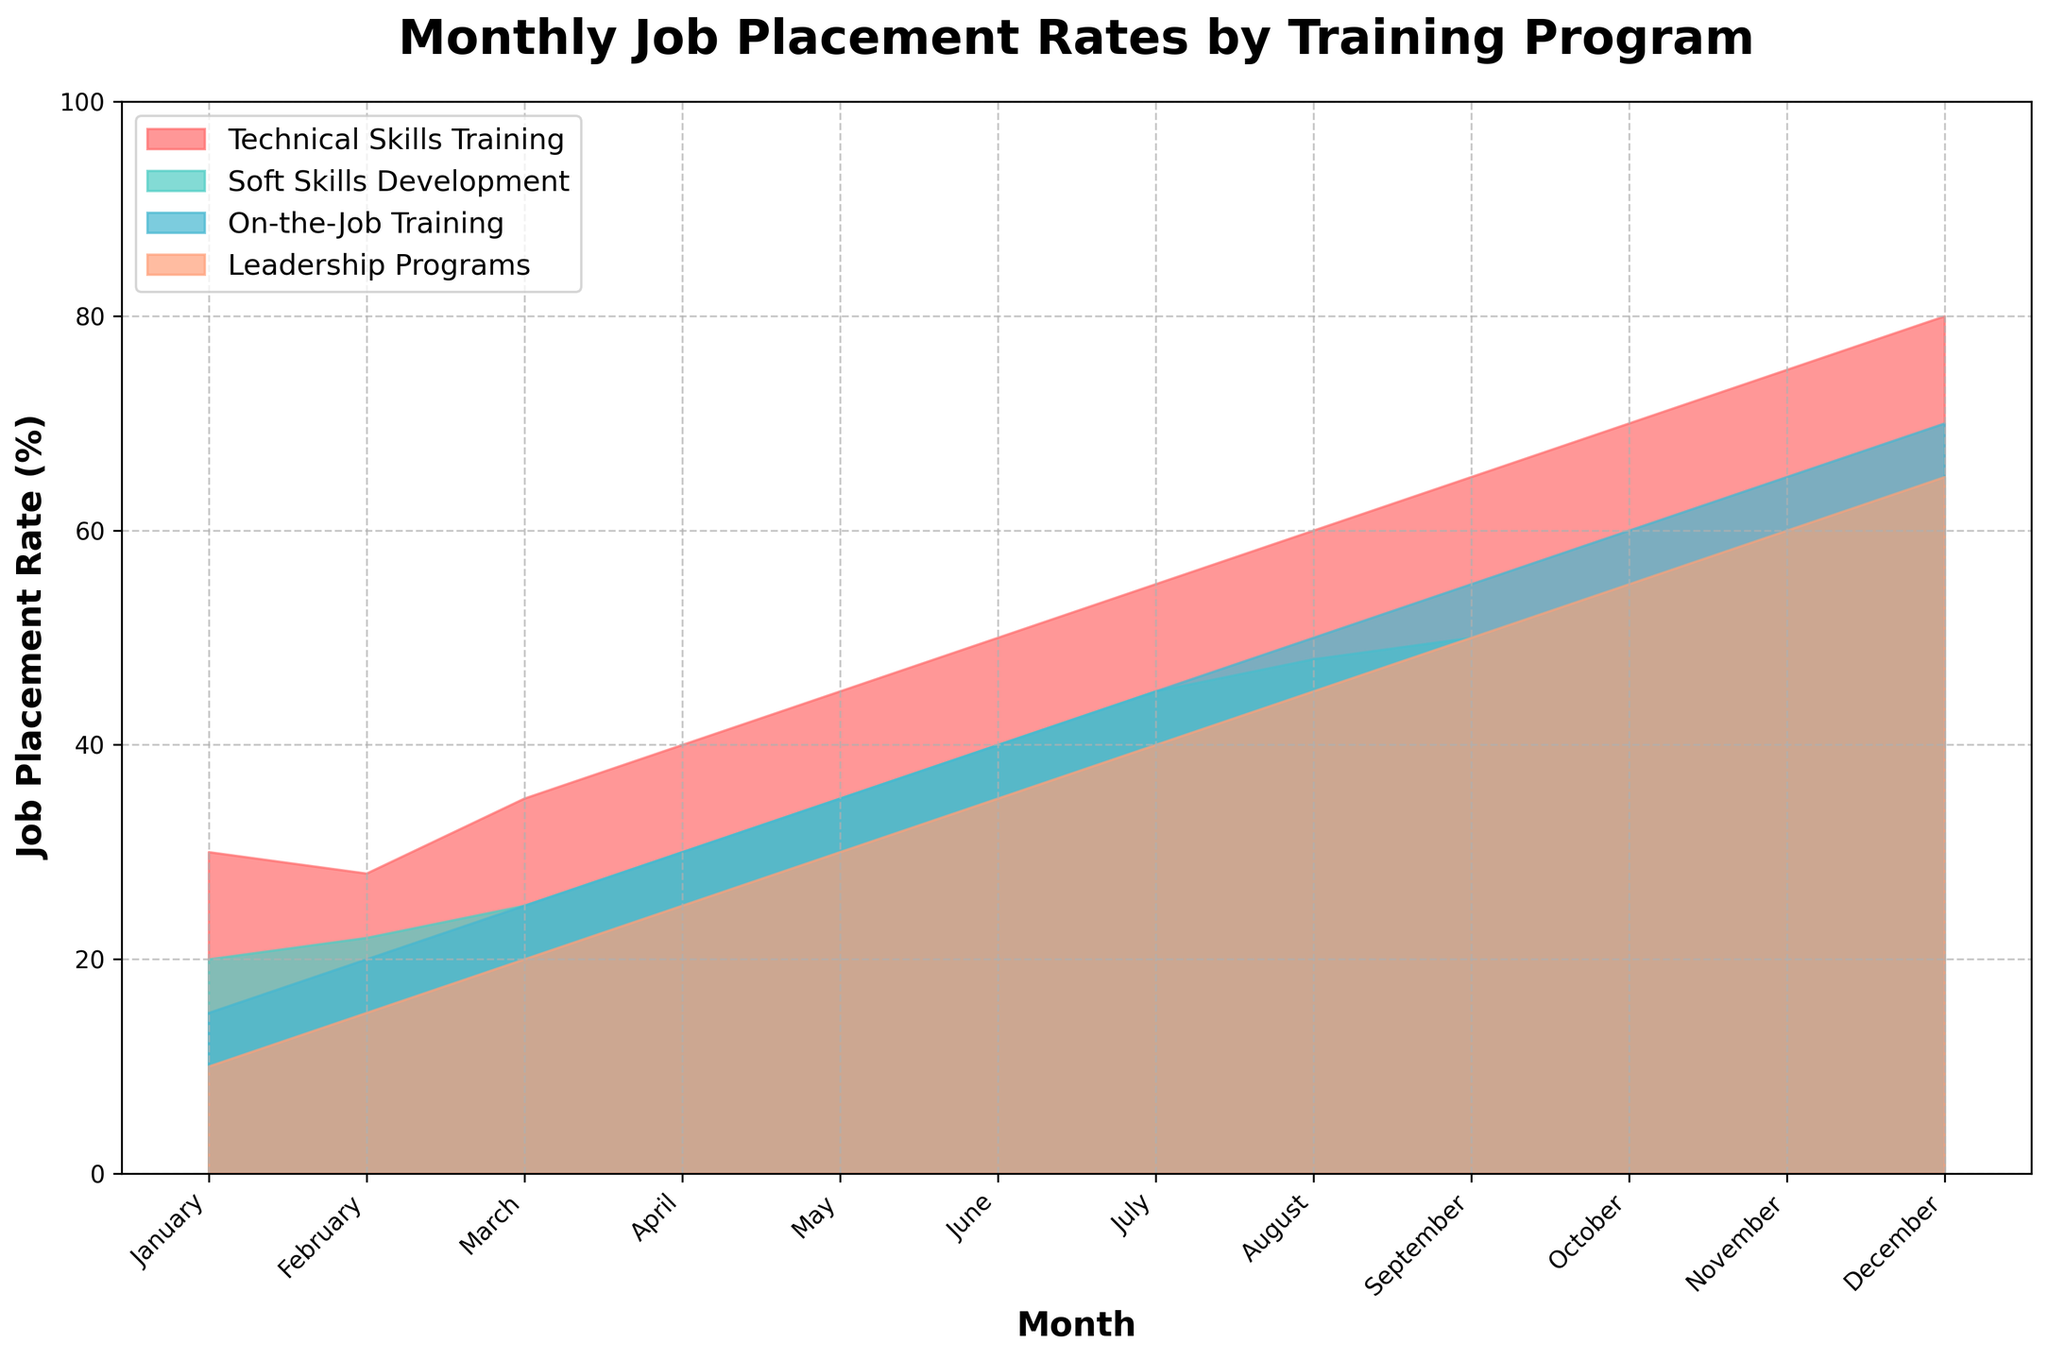What is the title of the chart? The title of the chart is typically found at the top and provides a brief description of what the chart is about. In this case, the title is "Monthly Job Placement Rates by Training Program".
Answer: Monthly Job Placement Rates by Training Program Which training program starts with the highest job placement rate in January? The colors and labeled areas of the chart represent different training programs, and by looking at the January data point for each program, we can see the highest starting value. Here, "Technical Skills Training" starts with the highest job placement rate in January with 30%.
Answer: Technical Skills Training What is the overall trend of job placement rates for all programs throughout the year? By observing the chart from January to December, we can see the pattern of each area. All programs show a positive trend, meaning job placement rates increase over the year.
Answer: Increasing How much does the job placement rate for "Technical Skills Training" increase from January to December? To determine the increase, subtract the starting value in January from the end value in December. For "Technical Skills Training", it's 80% in December minus 30% in January. The increase is 50 percentage points.
Answer: 50 percentage points Compare the job placement rates for "Soft Skills Development" and "On-the-Job Training" in June. Which one is higher and by how much? By locating June data points for both "Soft Skills Development" and "On-the-Job Training", we can compare the rates. "Soft Skills Development" has 40% and "On-the-Job Training" has 40%. Since the values are the same, there is no difference.
Answer: They are equal Which training program shows the least job placement rate increase from January to December? To determine this, calculate the increase for each program and compare. "Leadership Programs" increase from 10% to 65%, "On-the-Job Training" from 15% to 70%, "Soft Skills Development" from 20% to 65%, and "Technical Skills Training" from 30% to 80%. The smallest increase is for "Leadership Programs" with a 55 percentage point increase.
Answer: Leadership Programs At which month do "Soft Skills Development" and "Leadership Programs" have the same job placement rate? By examining the chart for when the areas of "Soft Skills Development" and "Leadership Programs" intersect, we can see this happens at December with a job placement rate of 65%.
Answer: December By how many percentage points does the job placement rate of "On-the-Job Training" change from February to October? Subtract the February value from the October value for "On-the-Job Training". It changes from 20% in February to 60% in October, which is an increase of 40 percentage points.
Answer: 40 percentage points Which training program has the highest job placement rate in July? By looking at the July data point for each program, we find "Technical Skills Training" has the highest rate at 55%.
Answer: Technical Skills Training 